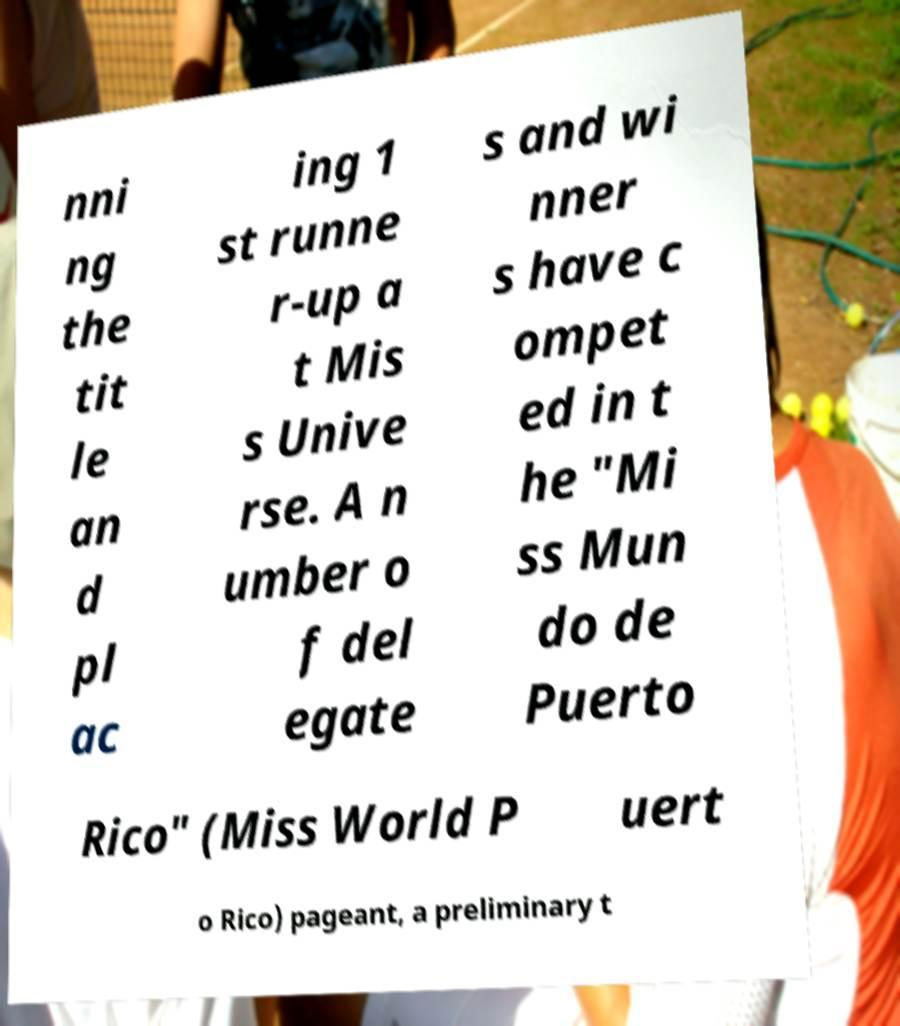There's text embedded in this image that I need extracted. Can you transcribe it verbatim? nni ng the tit le an d pl ac ing 1 st runne r-up a t Mis s Unive rse. A n umber o f del egate s and wi nner s have c ompet ed in t he "Mi ss Mun do de Puerto Rico" (Miss World P uert o Rico) pageant, a preliminary t 